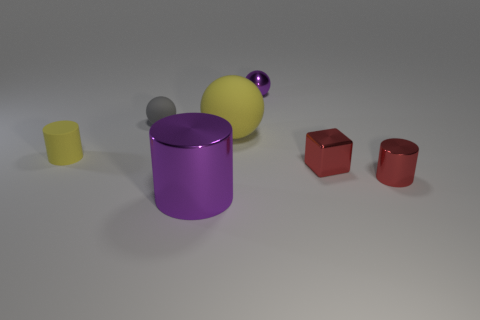Add 1 yellow things. How many objects exist? 8 Subtract all balls. How many objects are left? 4 Subtract all small metallic cubes. Subtract all large purple objects. How many objects are left? 5 Add 4 shiny cylinders. How many shiny cylinders are left? 6 Add 4 cyan balls. How many cyan balls exist? 4 Subtract 0 brown blocks. How many objects are left? 7 